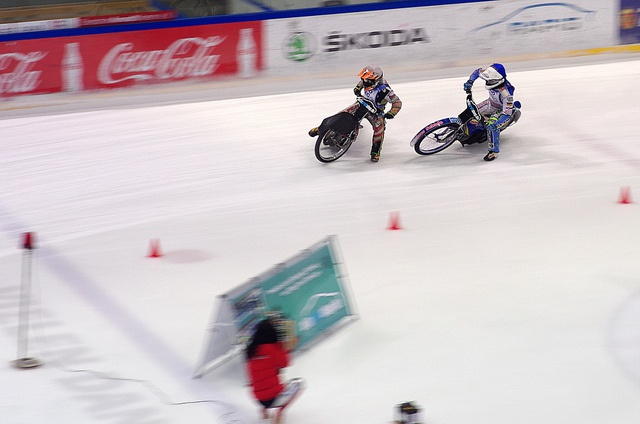Describe the objects in this image and their specific colors. I can see people in black, brown, and darkgray tones, people in black, lightgray, gray, and darkgray tones, motorcycle in black, gray, lightgray, and darkgray tones, people in black, gray, darkgray, and lightgray tones, and motorcycle in black, gray, darkgray, and lightgray tones in this image. 